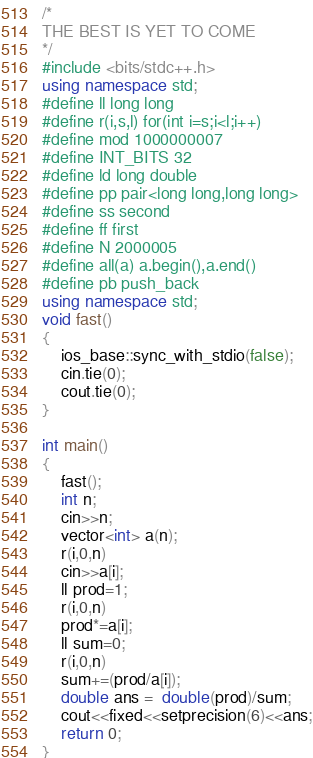Convert code to text. <code><loc_0><loc_0><loc_500><loc_500><_C++_>/*
THE BEST IS YET TO COME
*/
#include <bits/stdc++.h>
using namespace std;
#define ll long long
#define r(i,s,l) for(int i=s;i<l;i++)
#define mod 1000000007
#define INT_BITS 32
#define ld long double
#define pp pair<long long,long long>
#define ss second
#define ff first
#define N 2000005
#define all(a) a.begin(),a.end()
#define pb push_back
using namespace std;
void fast()
{
    ios_base::sync_with_stdio(false);
    cin.tie(0);
    cout.tie(0);
}

int main()
{
    fast();
    int n;
    cin>>n;
    vector<int> a(n);
    r(i,0,n)
    cin>>a[i];
    ll prod=1;
    r(i,0,n)
    prod*=a[i];
    ll sum=0;
    r(i,0,n)
    sum+=(prod/a[i]);
    double ans =  double(prod)/sum;
    cout<<fixed<<setprecision(6)<<ans;
	return 0;
}
</code> 